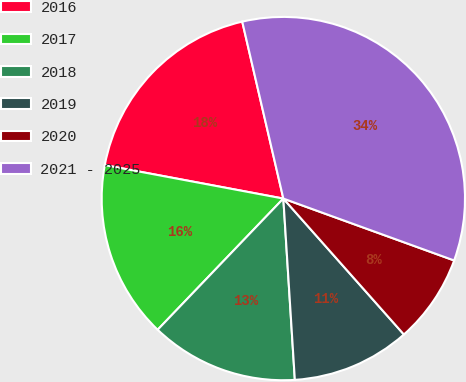<chart> <loc_0><loc_0><loc_500><loc_500><pie_chart><fcel>2016<fcel>2017<fcel>2018<fcel>2019<fcel>2020<fcel>2021 - 2025<nl><fcel>18.42%<fcel>15.79%<fcel>13.17%<fcel>10.54%<fcel>7.92%<fcel>34.17%<nl></chart> 